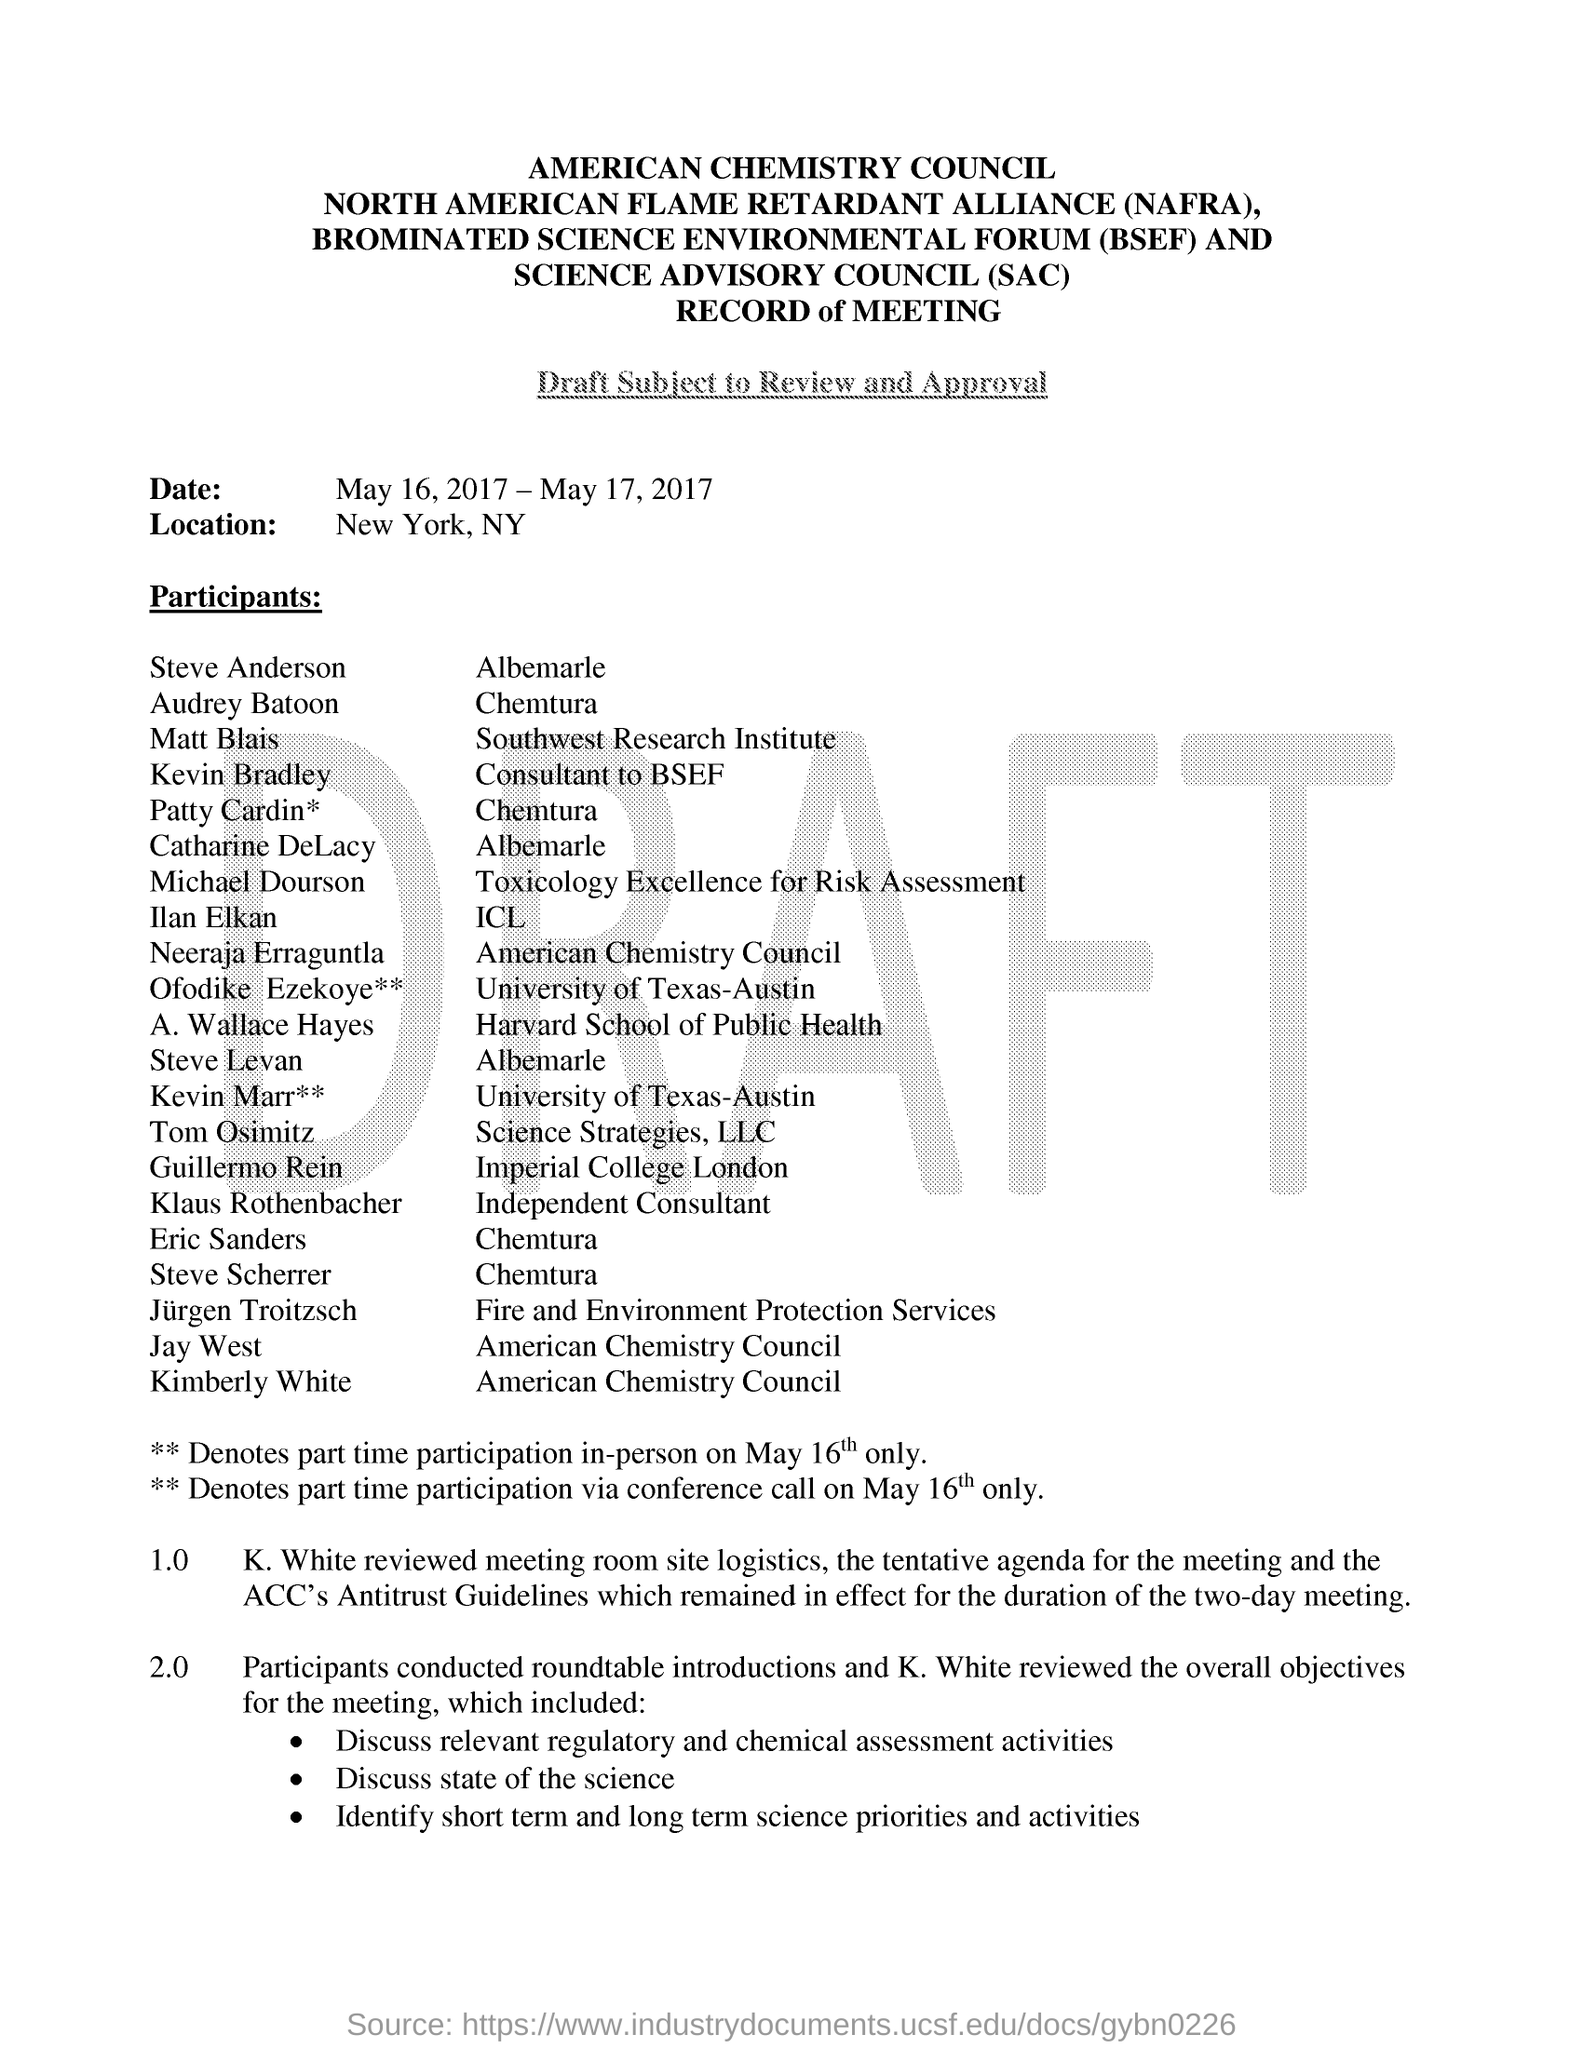What is the given location ?
Ensure brevity in your answer.  New York, NY. Who reviewed the overall objectives for the meeting ?
Your response must be concise. K. White. 